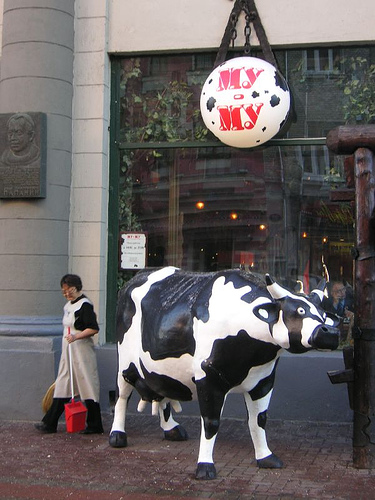<image>
Can you confirm if the ball is above the cow? Yes. The ball is positioned above the cow in the vertical space, higher up in the scene. 